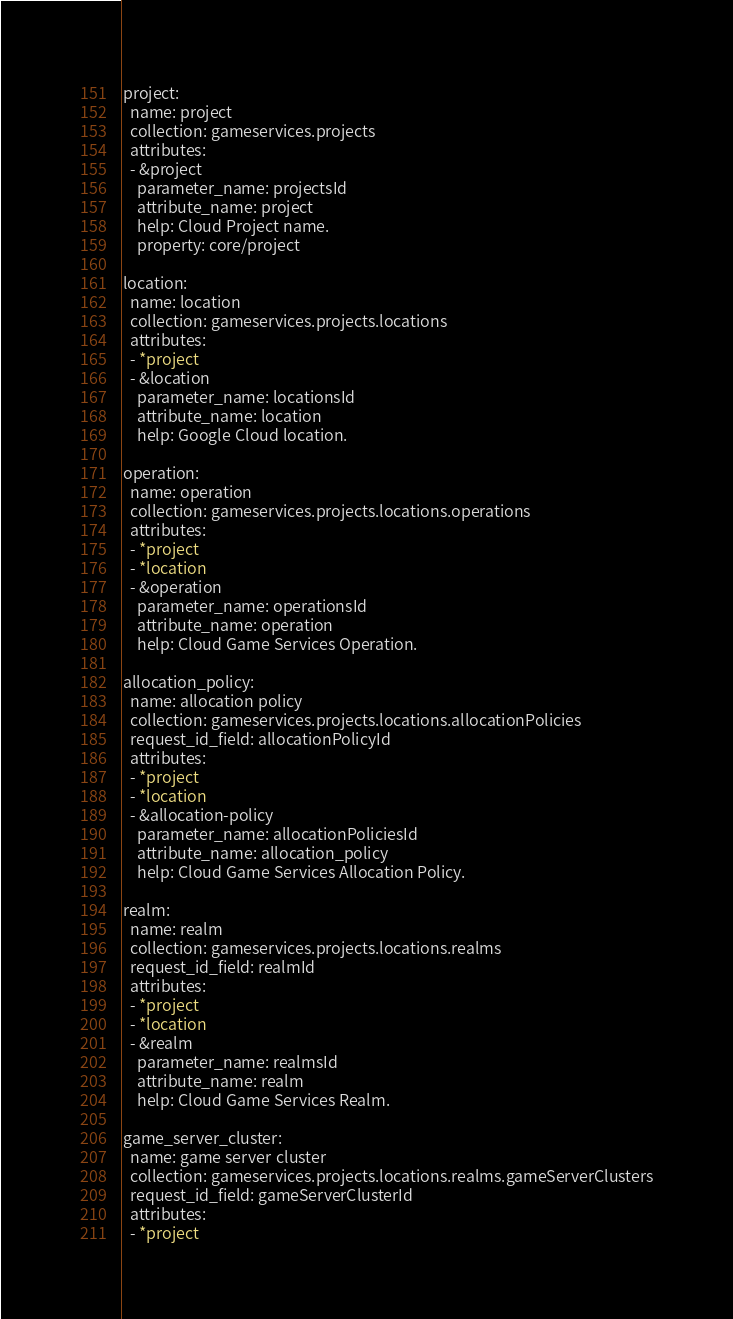Convert code to text. <code><loc_0><loc_0><loc_500><loc_500><_YAML_>project:
  name: project
  collection: gameservices.projects
  attributes:
  - &project
    parameter_name: projectsId
    attribute_name: project
    help: Cloud Project name.
    property: core/project

location:
  name: location
  collection: gameservices.projects.locations
  attributes:
  - *project
  - &location
    parameter_name: locationsId
    attribute_name: location
    help: Google Cloud location.

operation:
  name: operation
  collection: gameservices.projects.locations.operations
  attributes:
  - *project
  - *location
  - &operation
    parameter_name: operationsId
    attribute_name: operation
    help: Cloud Game Services Operation.

allocation_policy:
  name: allocation policy
  collection: gameservices.projects.locations.allocationPolicies
  request_id_field: allocationPolicyId
  attributes:
  - *project
  - *location
  - &allocation-policy
    parameter_name: allocationPoliciesId
    attribute_name: allocation_policy
    help: Cloud Game Services Allocation Policy.

realm:
  name: realm
  collection: gameservices.projects.locations.realms
  request_id_field: realmId
  attributes:
  - *project
  - *location
  - &realm
    parameter_name: realmsId
    attribute_name: realm
    help: Cloud Game Services Realm.

game_server_cluster:
  name: game server cluster
  collection: gameservices.projects.locations.realms.gameServerClusters
  request_id_field: gameServerClusterId
  attributes:
  - *project</code> 